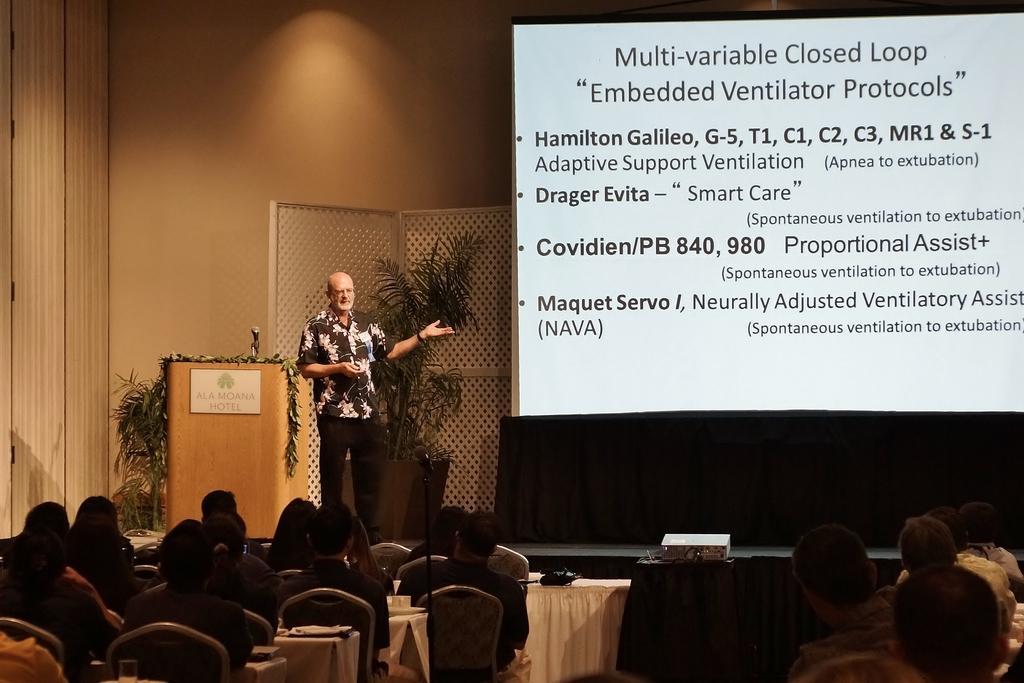Please provide a concise description of this image. As we can see in the image there are few people, chairs and plants. On the right side there is a screen. On screen there is something written and there is orange color wall. 